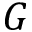<formula> <loc_0><loc_0><loc_500><loc_500>G</formula> 